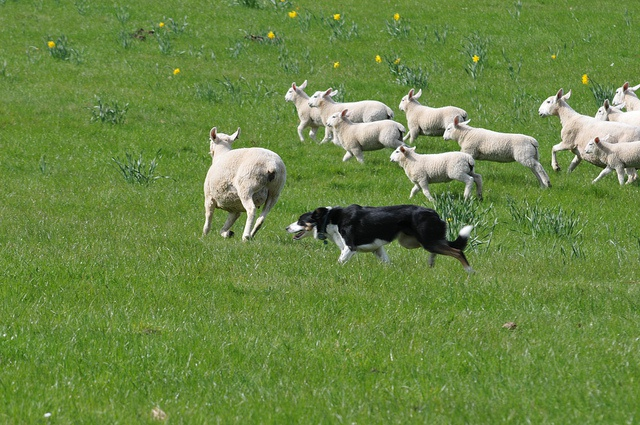Describe the objects in this image and their specific colors. I can see dog in green, black, olive, gray, and darkgreen tones, sheep in green, lightgray, gray, darkgreen, and darkgray tones, sheep in green, lightgray, darkgray, and gray tones, sheep in green, darkgray, lightgray, and gray tones, and sheep in green, lightgray, darkgray, and gray tones in this image. 